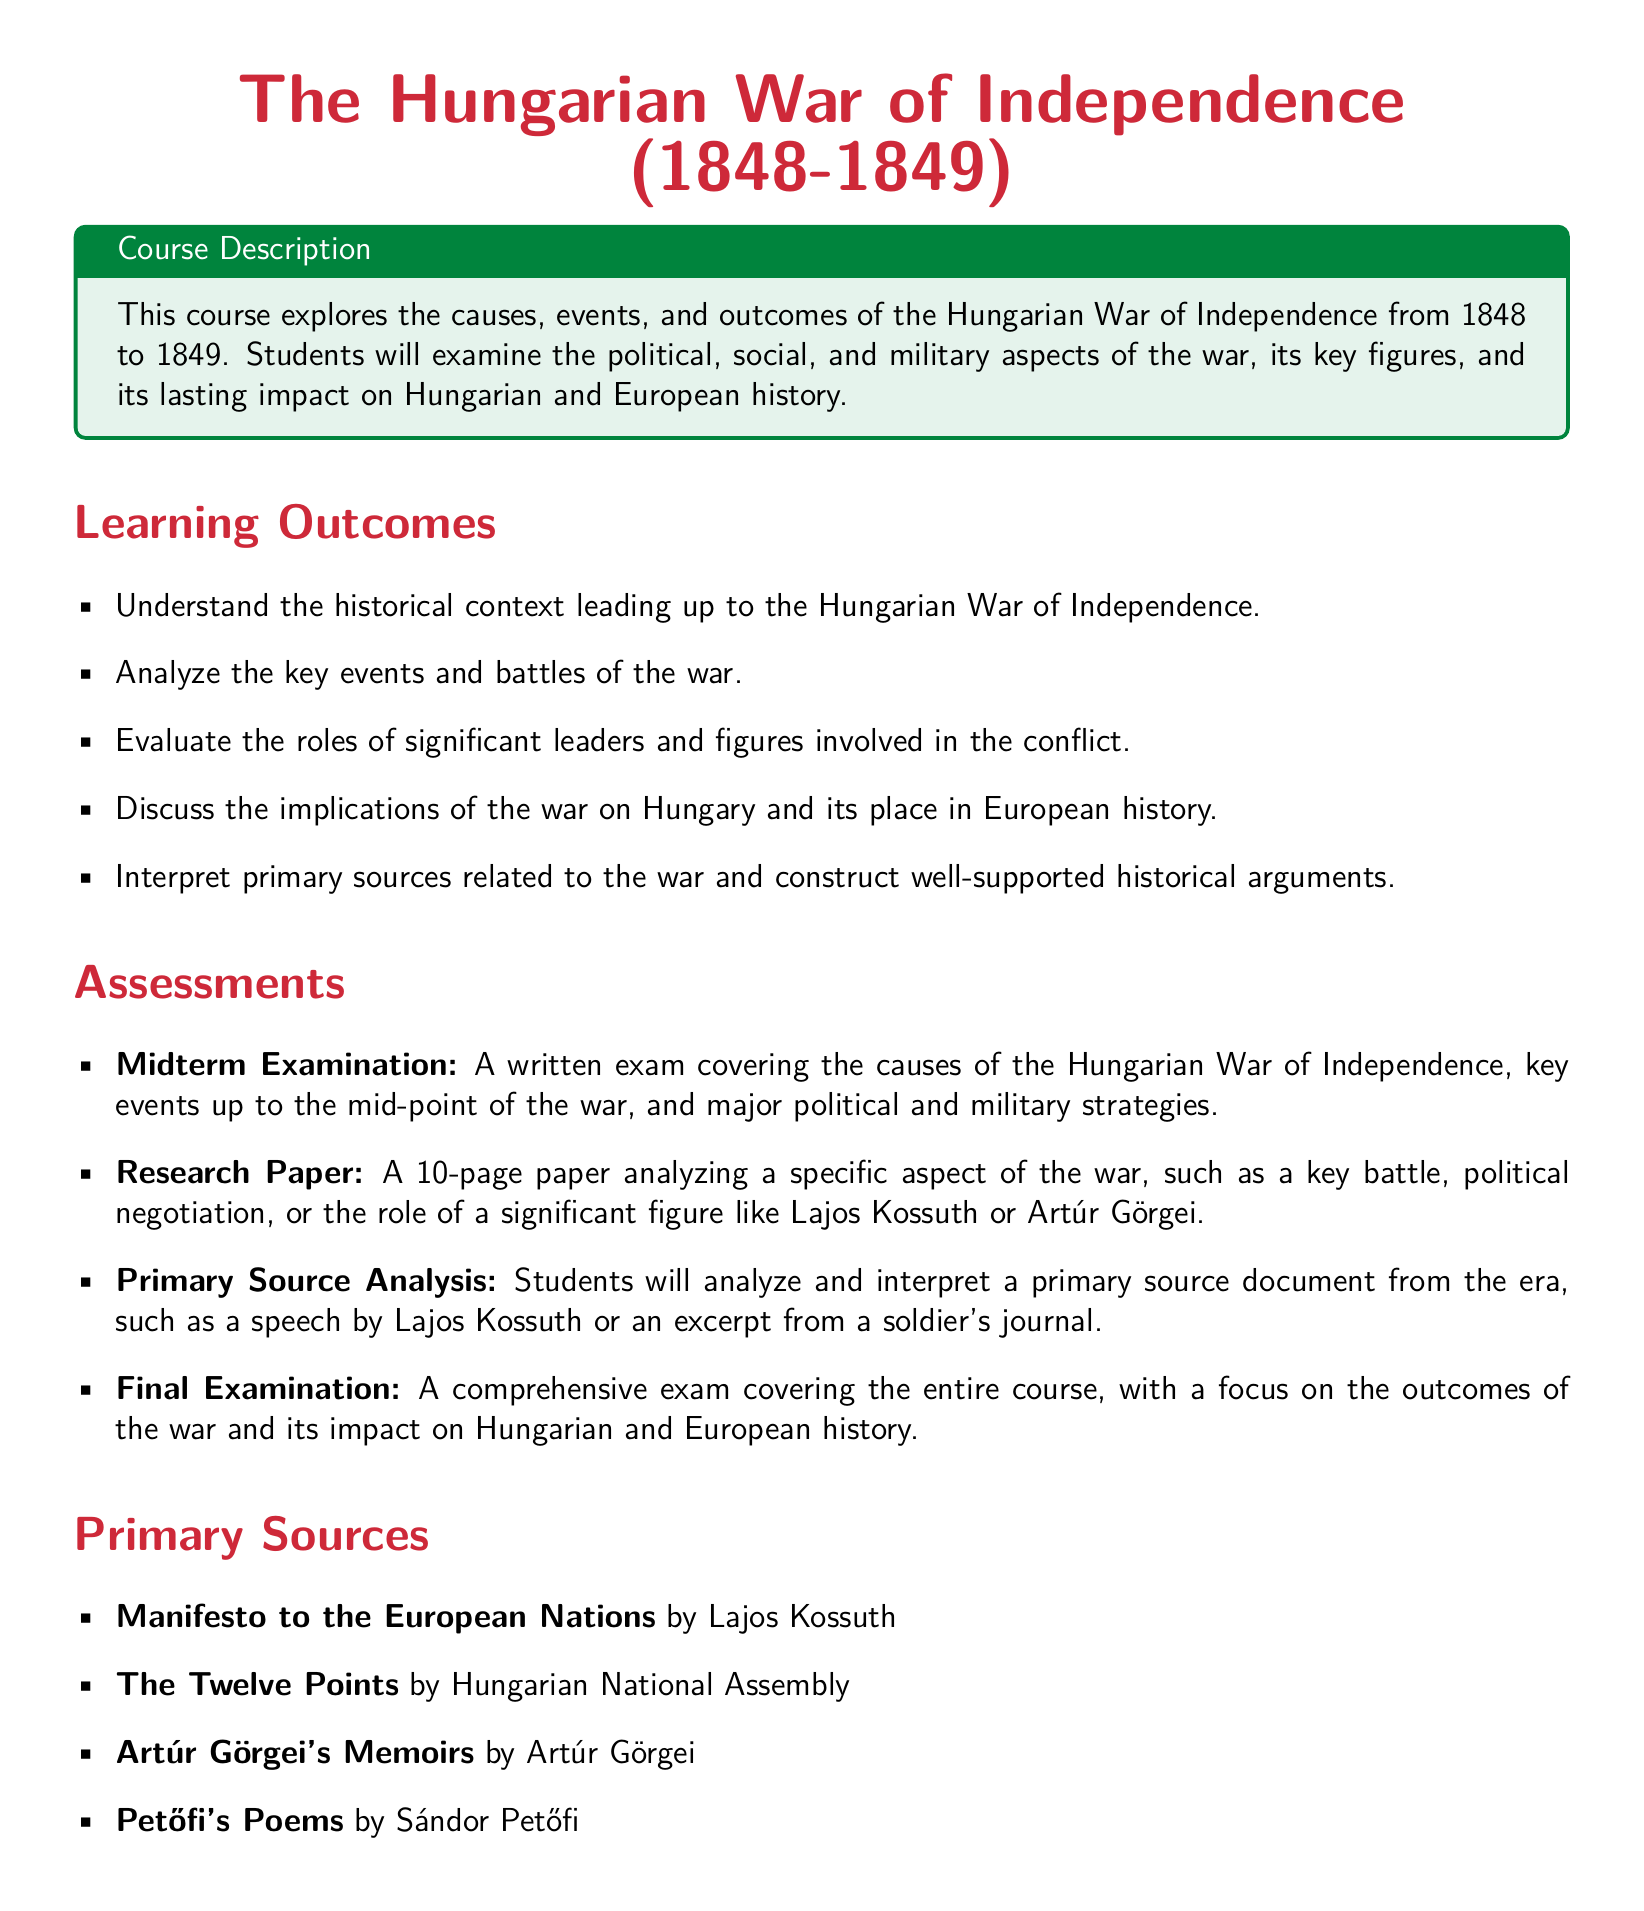What is the title of the course? The title of the course is stated prominently at the beginning of the document.
Answer: The Hungarian War of Independence (1848-1849) What is the first weekly topic listed? The first weekly topic outlines the introduction to the historical context of the course.
Answer: Introduction to 19th-century European Politics and Society Who is one key political figure mentioned in the course? The document lists significant political figures involved in the war, one of whom is Lajos Kossuth.
Answer: Lajos Kossuth What type of assessment is the "Primary Source Analysis"? The document categorizes assessments based on their nature and requirements.
Answer: Assessment How many pages is the research paper required to be? The document specifies the length of the research paper in the assessments section.
Answer: 10-page What is the Midterm Examination covering? The document outlines specific topics that will be assessed in the midterm exam.
Answer: Causes of the Hungarian War of Independence What primary source is authored by Sándor Petőfi? The document lists primary sources related to the war, identifying Petőfi's work.
Answer: Petőfi's Poems Which week includes a workshop for analyzing primary sources? The curriculum outlines a specific week dedicated to primary source analysis.
Answer: Primary Source Analysis Workshop What is the main focus of the Final Examination? The document specifies what students will be evaluated on in the final exam.
Answer: Outcomes of the war and its impact on Hungarian and European history 